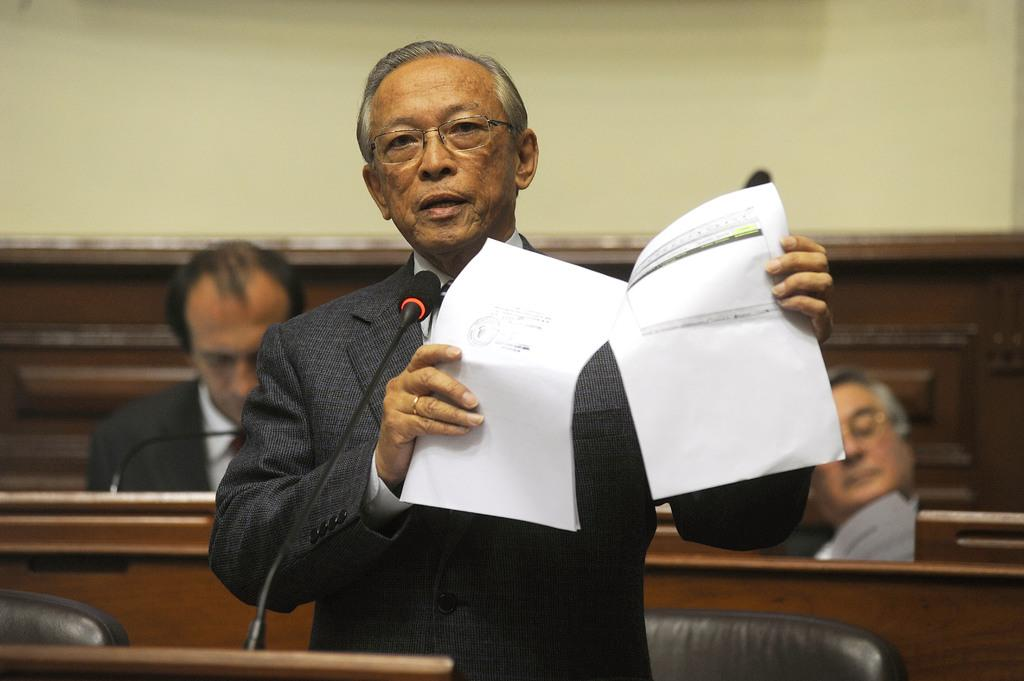What is the person in the image holding? The person is holding papers in the image. What object can be seen near the person? There is a microphone (mic) in the image. How many people are sitting in the background of the image? There are two people sitting in the background of the image. What type of chair is in the image? There is a black chair in the image. What color is the wall in the image? The wall is in cream color. What type of fruit is being used as a unit of measurement in the image? There is no fruit present in the image, nor is any unit of measurement being used. 